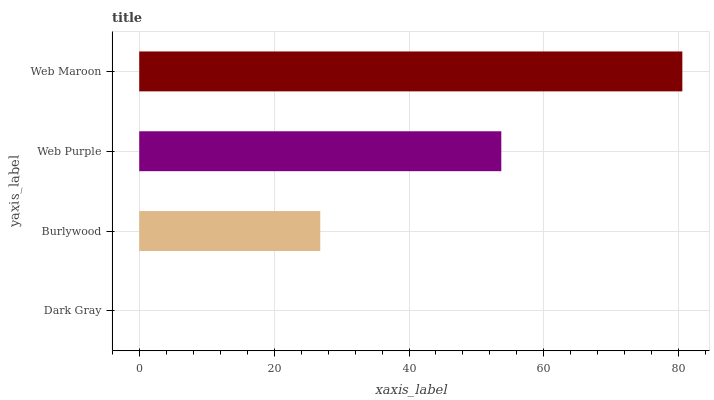Is Dark Gray the minimum?
Answer yes or no. Yes. Is Web Maroon the maximum?
Answer yes or no. Yes. Is Burlywood the minimum?
Answer yes or no. No. Is Burlywood the maximum?
Answer yes or no. No. Is Burlywood greater than Dark Gray?
Answer yes or no. Yes. Is Dark Gray less than Burlywood?
Answer yes or no. Yes. Is Dark Gray greater than Burlywood?
Answer yes or no. No. Is Burlywood less than Dark Gray?
Answer yes or no. No. Is Web Purple the high median?
Answer yes or no. Yes. Is Burlywood the low median?
Answer yes or no. Yes. Is Dark Gray the high median?
Answer yes or no. No. Is Dark Gray the low median?
Answer yes or no. No. 